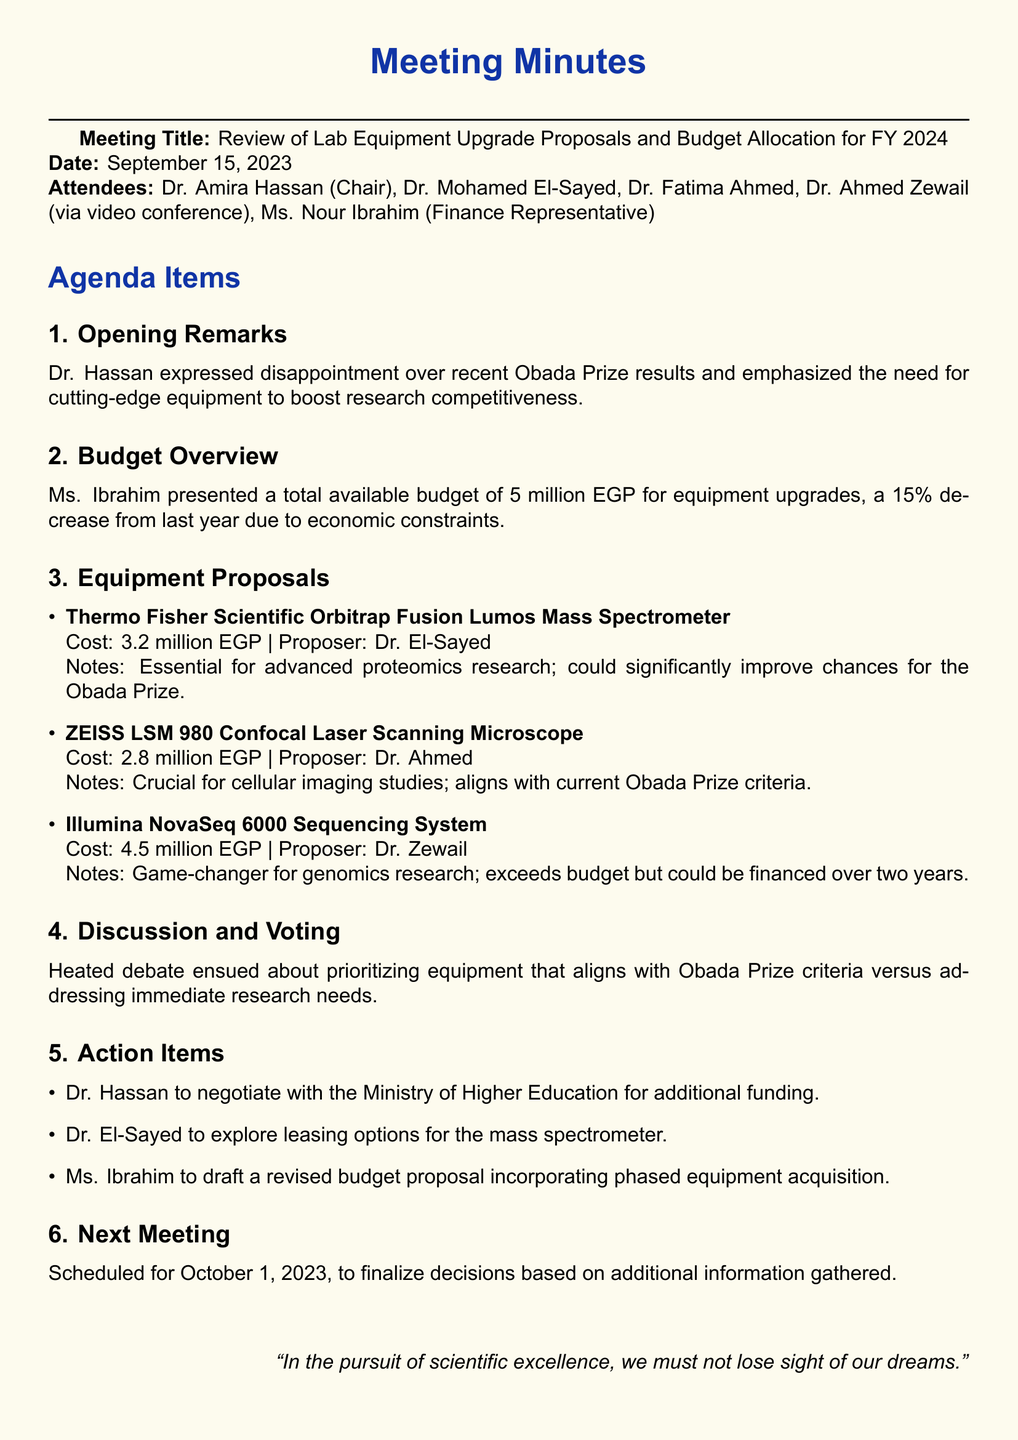what is the meeting title? The meeting title is specified at the beginning of the document.
Answer: Review of Lab Equipment Upgrade Proposals and Budget Allocation for FY 2024 who chaired the meeting? The chair of the meeting is mentioned in the attendee section.
Answer: Dr. Amira Hassan what was the total available budget for equipment upgrades? The total budget amount is stated in the budget overview section.
Answer: 5 million EGP who proposed the Thermo Fisher Scientific Orbitrap Fusion Lumos Mass Spectrometer? The proposer is listed next to the equipment proposal.
Answer: Dr. El-Sayed how much does the Illumina NovaSeq 6000 Sequencing System cost? The cost of the system is provided within its proposal details.
Answer: 4.5 million EGP what percentage decrease is there in the budget from last year? The percentage decrease is included in the budget overview notes.
Answer: 15% when is the next meeting scheduled? The next meeting date is noted at the end of the document.
Answer: October 1, 2023 what did Dr. Hassan emphasize in her opening remarks? The emphasis is discussed in the opening remarks section.
Answer: need for cutting-edge equipment what action item involves negotiating for additional funding? The action items section lists who is responsible for negotiating.
Answer: Dr. Hassan 